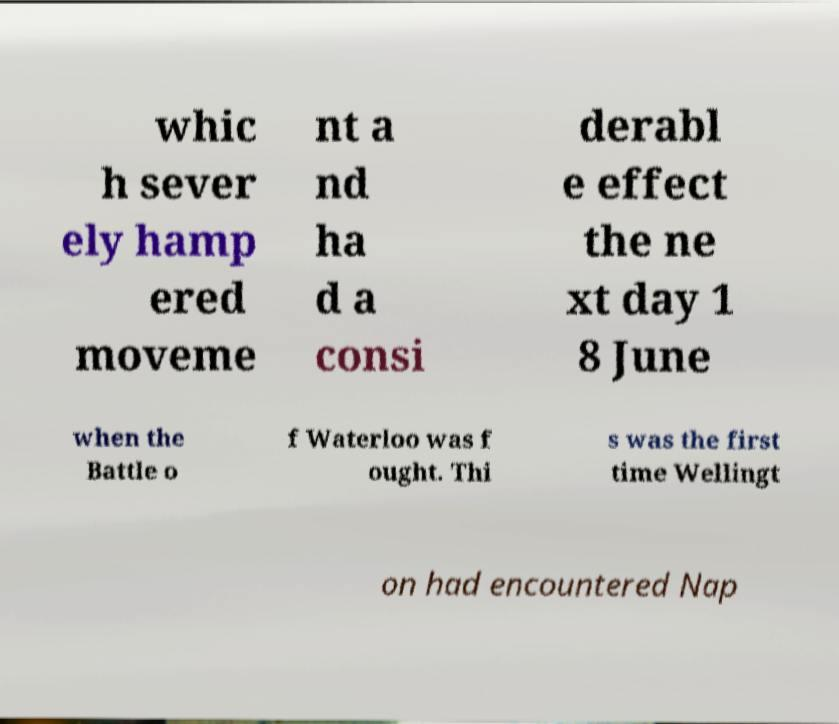Can you read and provide the text displayed in the image?This photo seems to have some interesting text. Can you extract and type it out for me? whic h sever ely hamp ered moveme nt a nd ha d a consi derabl e effect the ne xt day 1 8 June when the Battle o f Waterloo was f ought. Thi s was the first time Wellingt on had encountered Nap 